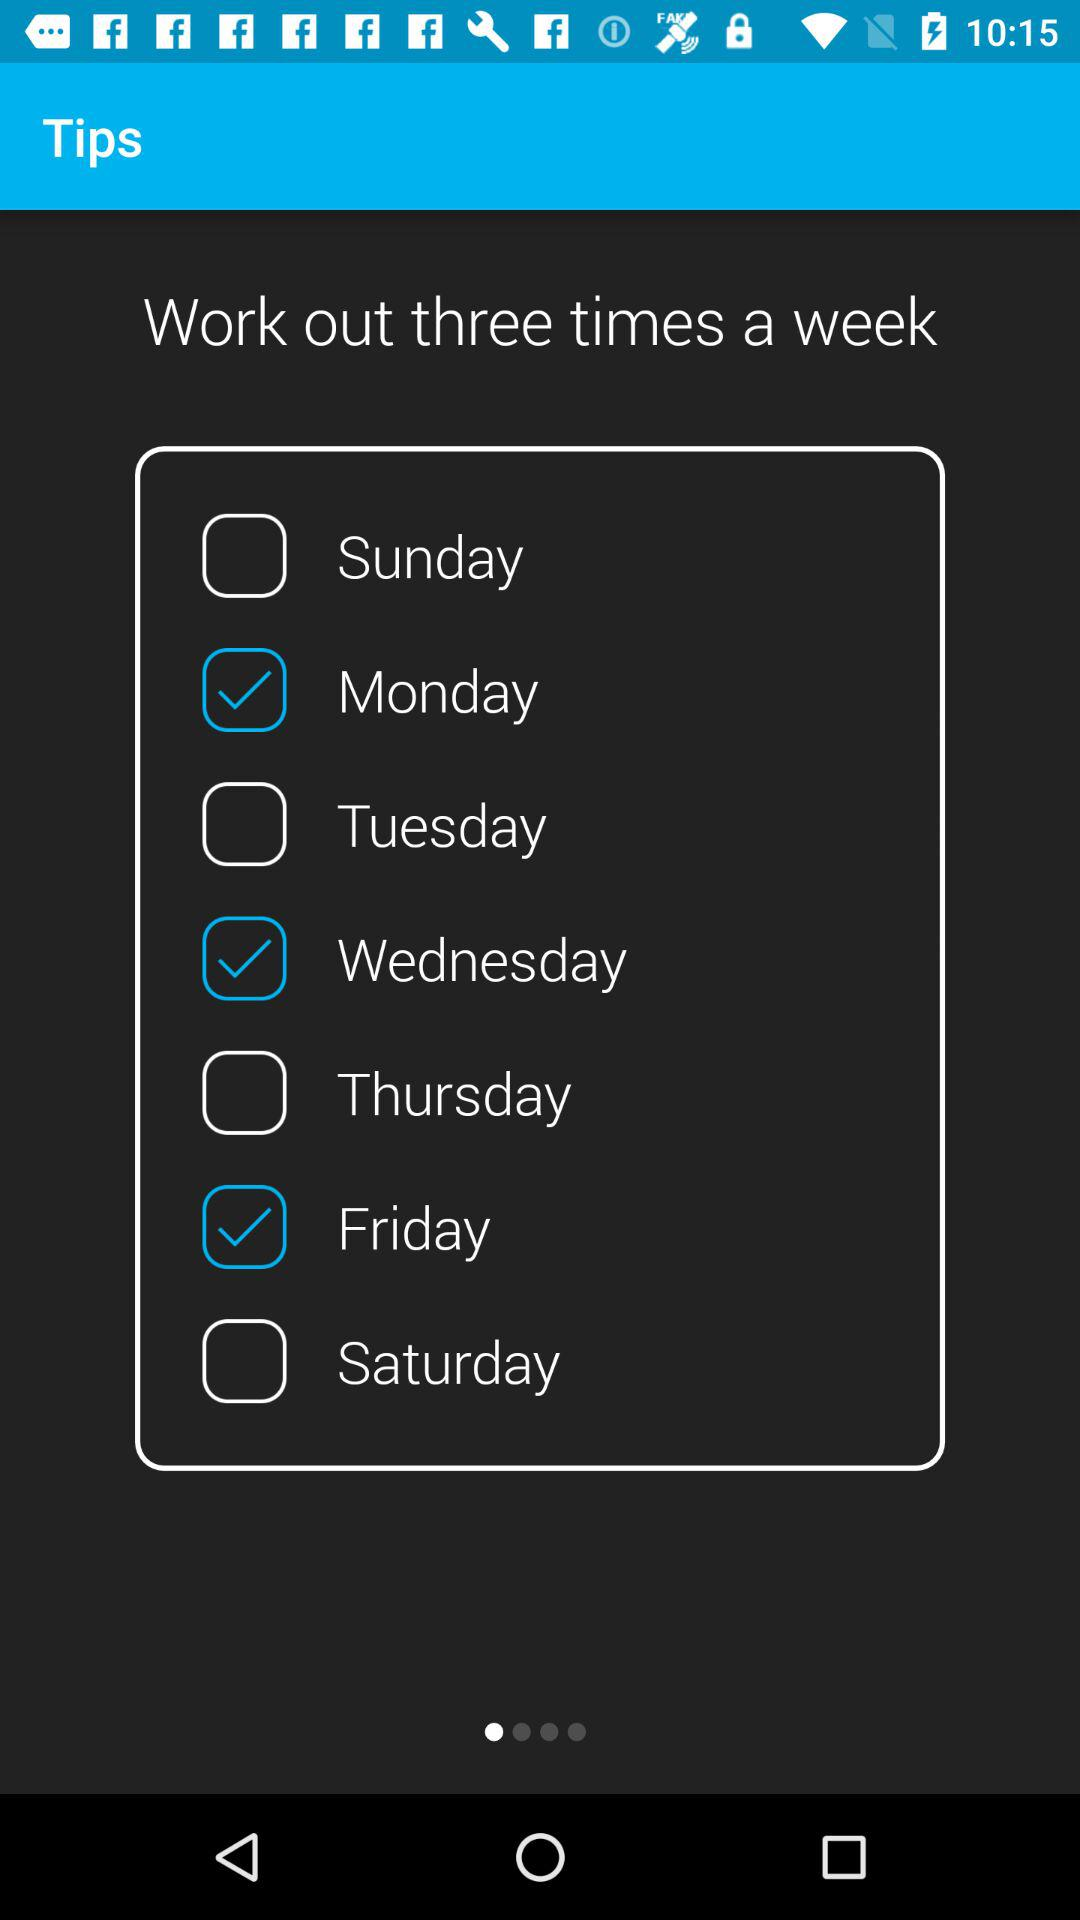How many times a week do users have to work out? Users have to work out three times a week. 